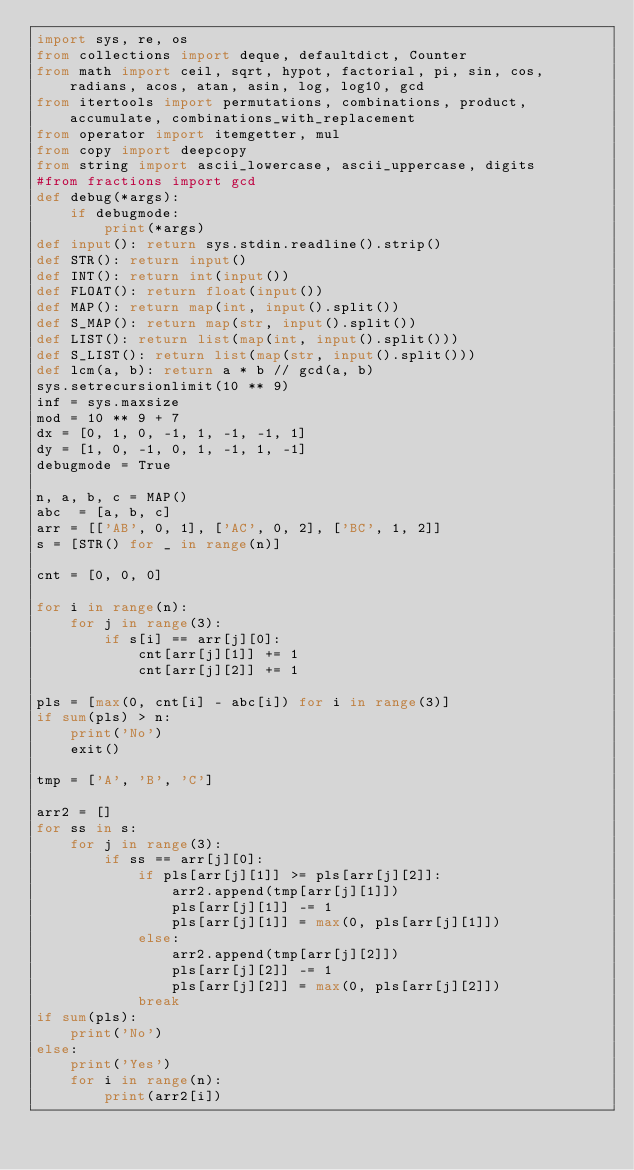<code> <loc_0><loc_0><loc_500><loc_500><_Python_>import sys, re, os
from collections import deque, defaultdict, Counter
from math import ceil, sqrt, hypot, factorial, pi, sin, cos, radians, acos, atan, asin, log, log10, gcd
from itertools import permutations, combinations, product, accumulate, combinations_with_replacement
from operator import itemgetter, mul
from copy import deepcopy
from string import ascii_lowercase, ascii_uppercase, digits
#from fractions import gcd
def debug(*args):
    if debugmode:
        print(*args)
def input(): return sys.stdin.readline().strip()
def STR(): return input()
def INT(): return int(input())
def FLOAT(): return float(input())
def MAP(): return map(int, input().split())
def S_MAP(): return map(str, input().split())
def LIST(): return list(map(int, input().split()))
def S_LIST(): return list(map(str, input().split()))
def lcm(a, b): return a * b // gcd(a, b)
sys.setrecursionlimit(10 ** 9)
inf = sys.maxsize
mod = 10 ** 9 + 7
dx = [0, 1, 0, -1, 1, -1, -1, 1]
dy = [1, 0, -1, 0, 1, -1, 1, -1]
debugmode = True

n, a, b, c = MAP()
abc  = [a, b, c]
arr = [['AB', 0, 1], ['AC', 0, 2], ['BC', 1, 2]]
s = [STR() for _ in range(n)]

cnt = [0, 0, 0]

for i in range(n):
    for j in range(3):
        if s[i] == arr[j][0]:
            cnt[arr[j][1]] += 1
            cnt[arr[j][2]] += 1

pls = [max(0, cnt[i] - abc[i]) for i in range(3)]
if sum(pls) > n:
    print('No')
    exit()

tmp = ['A', 'B', 'C']

arr2 = []
for ss in s:
    for j in range(3):
        if ss == arr[j][0]:
            if pls[arr[j][1]] >= pls[arr[j][2]]:
                arr2.append(tmp[arr[j][1]])
                pls[arr[j][1]] -= 1
                pls[arr[j][1]] = max(0, pls[arr[j][1]])
            else:
                arr2.append(tmp[arr[j][2]])
                pls[arr[j][2]] -= 1
                pls[arr[j][2]] = max(0, pls[arr[j][2]])
            break
if sum(pls):
    print('No')
else:
    print('Yes')
    for i in range(n):
        print(arr2[i])
</code> 